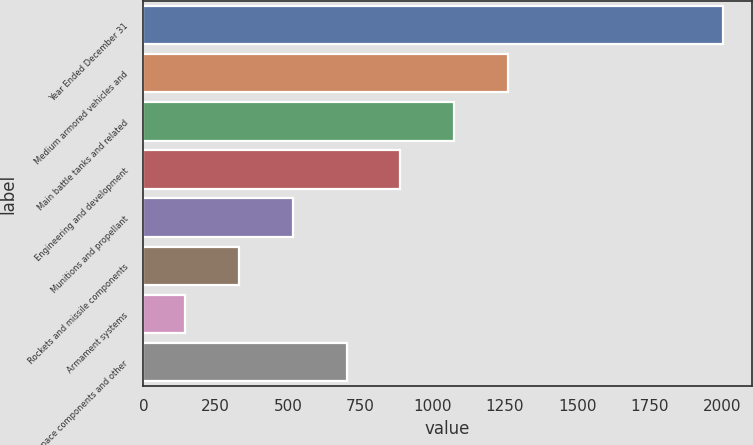Convert chart to OTSL. <chart><loc_0><loc_0><loc_500><loc_500><bar_chart><fcel>Year Ended December 31<fcel>Medium armored vehicles and<fcel>Main battle tanks and related<fcel>Engineering and development<fcel>Munitions and propellant<fcel>Rockets and missile components<fcel>Armament systems<fcel>Aerospace components and other<nl><fcel>2003<fcel>1259.8<fcel>1074<fcel>888.2<fcel>516.6<fcel>330.8<fcel>145<fcel>702.4<nl></chart> 